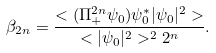<formula> <loc_0><loc_0><loc_500><loc_500>\beta _ { 2 n } = \frac { < ( \Pi _ { + } ^ { 2 n } \psi _ { 0 } ) \psi _ { 0 } ^ { \ast } | \psi _ { 0 } | ^ { 2 } > } { < | \psi _ { 0 } | ^ { 2 } > ^ { 2 } 2 ^ { n } } .</formula> 